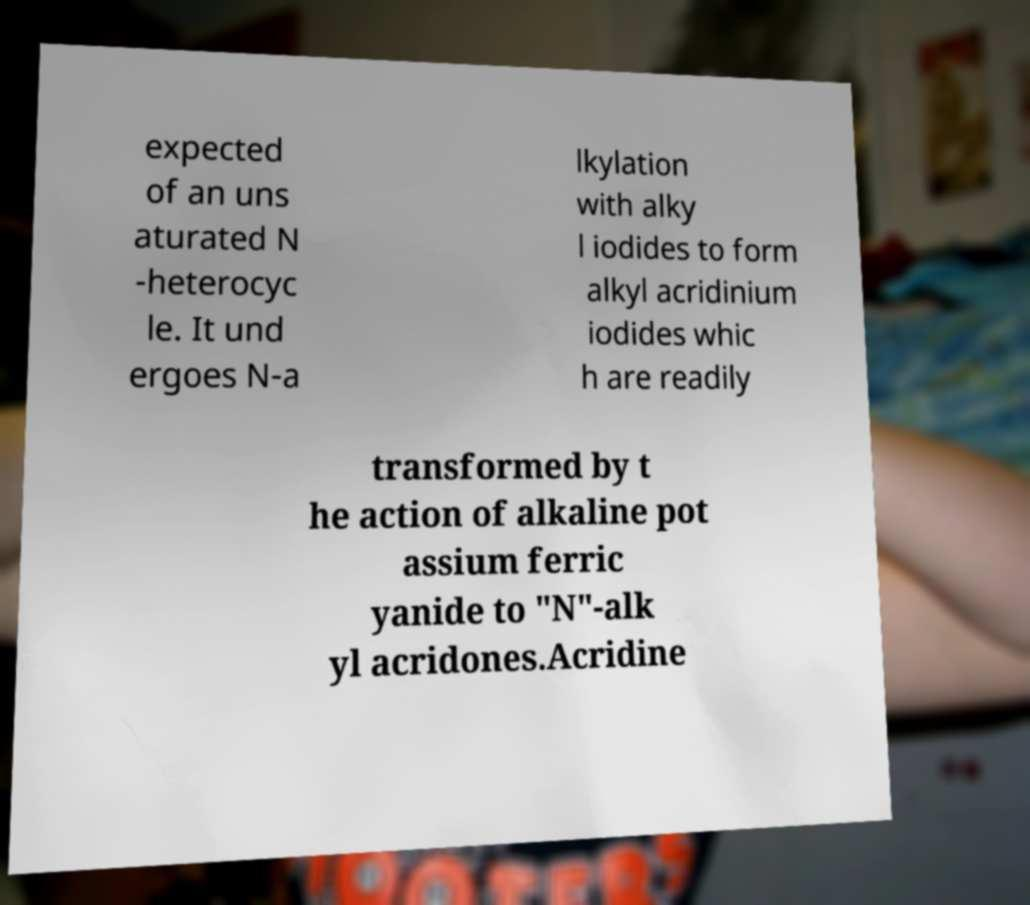I need the written content from this picture converted into text. Can you do that? expected of an uns aturated N -heterocyc le. It und ergoes N-a lkylation with alky l iodides to form alkyl acridinium iodides whic h are readily transformed by t he action of alkaline pot assium ferric yanide to "N"-alk yl acridones.Acridine 